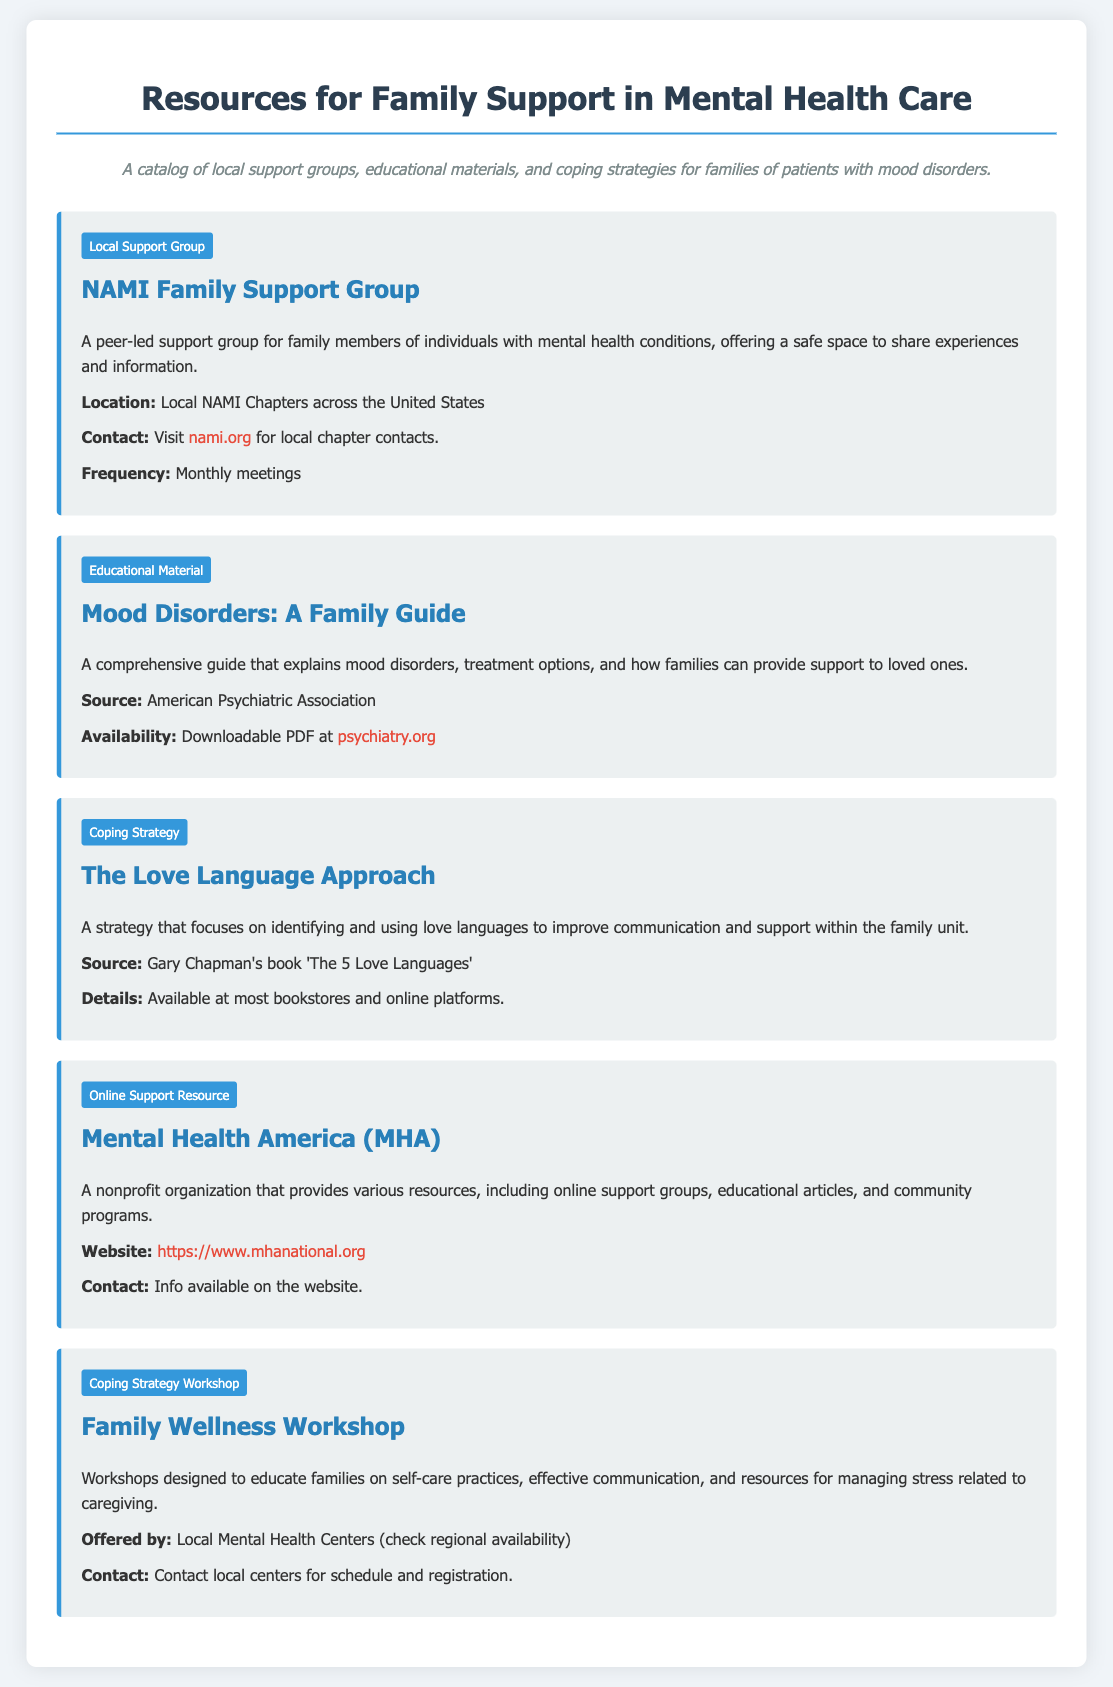What is the name of the local support group? The document lists the NAMI Family Support Group as the local support group available for family members.
Answer: NAMI Family Support Group How often do meetings occur for the NAMI Family Support Group? The document specifies that the NAMI Family Support Group holds monthly meetings for family members.
Answer: Monthly meetings Where can you find the downloadable PDF guide on mood disorders? The document provides a link to the American Psychiatric Association's website for the downloadable PDF.
Answer: psychiatry.org What is the title of the educational material mentioned in the document? The document mentions "Mood Disorders: A Family Guide" as the title of the educational material available.
Answer: Mood Disorders: A Family Guide What is the primary focus of "The Love Language Approach"? The document states that this strategy focuses on identifying and using love languages to improve communication within the family.
Answer: Improve communication Which organization provides online support groups and educational articles? The document indicates that Mental Health America (MHA) offers various resources, including online support groups and educational articles.
Answer: Mental Health America (MHA) What type of workshop is discussed in the document? The document describes a workshop aimed at educating families about self-care practices, communication, and managing stress.
Answer: Family Wellness Workshop Who provides contact information for local resources related to workshops? The document specifies that local mental health centers provide contact information for inquiries about workshops.
Answer: Local Mental Health Centers 